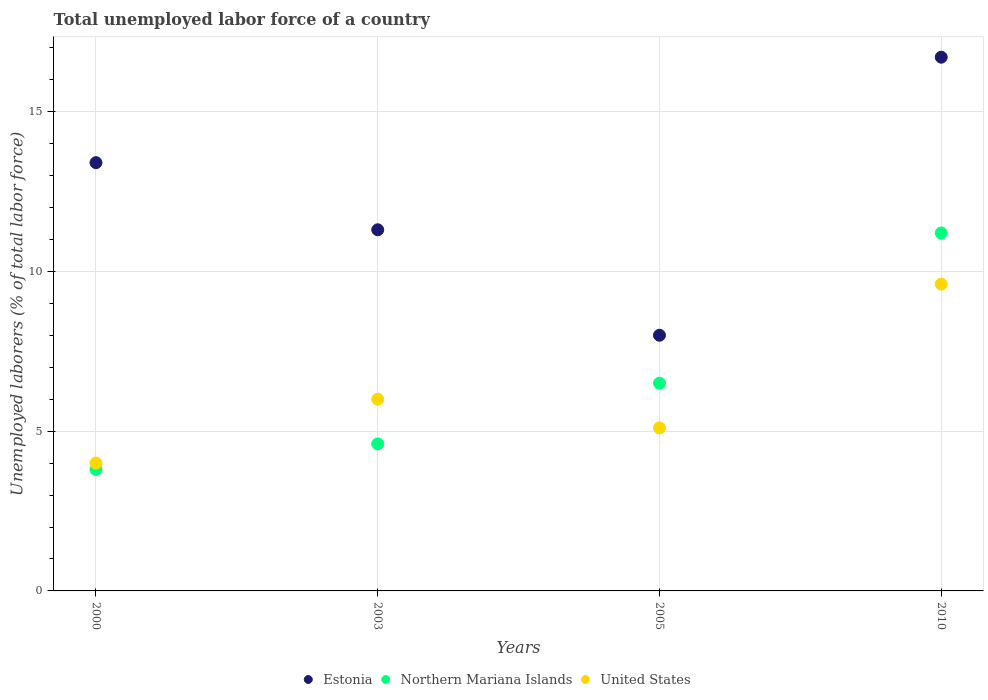How many different coloured dotlines are there?
Offer a terse response. 3. What is the total unemployed labor force in Estonia in 2003?
Your response must be concise. 11.3. Across all years, what is the maximum total unemployed labor force in Estonia?
Your answer should be very brief. 16.7. Across all years, what is the minimum total unemployed labor force in Northern Mariana Islands?
Ensure brevity in your answer.  3.8. What is the total total unemployed labor force in Northern Mariana Islands in the graph?
Offer a very short reply. 26.1. What is the difference between the total unemployed labor force in United States in 2000 and that in 2010?
Make the answer very short. -5.6. What is the difference between the total unemployed labor force in Northern Mariana Islands in 2003 and the total unemployed labor force in Estonia in 2000?
Give a very brief answer. -8.8. What is the average total unemployed labor force in United States per year?
Ensure brevity in your answer.  6.18. In the year 2010, what is the difference between the total unemployed labor force in Northern Mariana Islands and total unemployed labor force in Estonia?
Give a very brief answer. -5.5. In how many years, is the total unemployed labor force in United States greater than 3 %?
Provide a succinct answer. 4. What is the ratio of the total unemployed labor force in Estonia in 2000 to that in 2010?
Make the answer very short. 0.8. What is the difference between the highest and the second highest total unemployed labor force in United States?
Your response must be concise. 3.6. What is the difference between the highest and the lowest total unemployed labor force in Estonia?
Your answer should be very brief. 8.7. Is the sum of the total unemployed labor force in United States in 2003 and 2005 greater than the maximum total unemployed labor force in Estonia across all years?
Ensure brevity in your answer.  No. Is it the case that in every year, the sum of the total unemployed labor force in Northern Mariana Islands and total unemployed labor force in Estonia  is greater than the total unemployed labor force in United States?
Provide a succinct answer. Yes. Is the total unemployed labor force in United States strictly less than the total unemployed labor force in Northern Mariana Islands over the years?
Offer a terse response. No. How many years are there in the graph?
Offer a very short reply. 4. Does the graph contain any zero values?
Your answer should be very brief. No. Does the graph contain grids?
Give a very brief answer. Yes. How are the legend labels stacked?
Offer a terse response. Horizontal. What is the title of the graph?
Provide a succinct answer. Total unemployed labor force of a country. What is the label or title of the Y-axis?
Ensure brevity in your answer.  Unemployed laborers (% of total labor force). What is the Unemployed laborers (% of total labor force) in Estonia in 2000?
Keep it short and to the point. 13.4. What is the Unemployed laborers (% of total labor force) in Northern Mariana Islands in 2000?
Offer a terse response. 3.8. What is the Unemployed laborers (% of total labor force) of United States in 2000?
Keep it short and to the point. 4. What is the Unemployed laborers (% of total labor force) in Estonia in 2003?
Your answer should be compact. 11.3. What is the Unemployed laborers (% of total labor force) in Northern Mariana Islands in 2003?
Your answer should be compact. 4.6. What is the Unemployed laborers (% of total labor force) of United States in 2003?
Make the answer very short. 6. What is the Unemployed laborers (% of total labor force) in Estonia in 2005?
Offer a very short reply. 8. What is the Unemployed laborers (% of total labor force) of Northern Mariana Islands in 2005?
Your response must be concise. 6.5. What is the Unemployed laborers (% of total labor force) in United States in 2005?
Offer a terse response. 5.1. What is the Unemployed laborers (% of total labor force) of Estonia in 2010?
Offer a terse response. 16.7. What is the Unemployed laborers (% of total labor force) in Northern Mariana Islands in 2010?
Provide a succinct answer. 11.2. What is the Unemployed laborers (% of total labor force) in United States in 2010?
Your answer should be very brief. 9.6. Across all years, what is the maximum Unemployed laborers (% of total labor force) of Estonia?
Provide a succinct answer. 16.7. Across all years, what is the maximum Unemployed laborers (% of total labor force) of Northern Mariana Islands?
Provide a succinct answer. 11.2. Across all years, what is the maximum Unemployed laborers (% of total labor force) of United States?
Offer a terse response. 9.6. Across all years, what is the minimum Unemployed laborers (% of total labor force) of Northern Mariana Islands?
Offer a terse response. 3.8. What is the total Unemployed laborers (% of total labor force) in Estonia in the graph?
Provide a short and direct response. 49.4. What is the total Unemployed laborers (% of total labor force) of Northern Mariana Islands in the graph?
Offer a terse response. 26.1. What is the total Unemployed laborers (% of total labor force) in United States in the graph?
Provide a succinct answer. 24.7. What is the difference between the Unemployed laborers (% of total labor force) in Northern Mariana Islands in 2000 and that in 2003?
Your answer should be compact. -0.8. What is the difference between the Unemployed laborers (% of total labor force) in United States in 2000 and that in 2003?
Your answer should be compact. -2. What is the difference between the Unemployed laborers (% of total labor force) in Estonia in 2000 and that in 2005?
Ensure brevity in your answer.  5.4. What is the difference between the Unemployed laborers (% of total labor force) in Northern Mariana Islands in 2000 and that in 2005?
Offer a terse response. -2.7. What is the difference between the Unemployed laborers (% of total labor force) of Estonia in 2000 and that in 2010?
Keep it short and to the point. -3.3. What is the difference between the Unemployed laborers (% of total labor force) in United States in 2000 and that in 2010?
Make the answer very short. -5.6. What is the difference between the Unemployed laborers (% of total labor force) of Northern Mariana Islands in 2003 and that in 2010?
Your answer should be very brief. -6.6. What is the difference between the Unemployed laborers (% of total labor force) of United States in 2003 and that in 2010?
Offer a very short reply. -3.6. What is the difference between the Unemployed laborers (% of total labor force) of Estonia in 2005 and that in 2010?
Make the answer very short. -8.7. What is the difference between the Unemployed laborers (% of total labor force) in Northern Mariana Islands in 2005 and that in 2010?
Offer a very short reply. -4.7. What is the difference between the Unemployed laborers (% of total labor force) in Estonia in 2000 and the Unemployed laborers (% of total labor force) in Northern Mariana Islands in 2005?
Provide a succinct answer. 6.9. What is the difference between the Unemployed laborers (% of total labor force) in Estonia in 2003 and the Unemployed laborers (% of total labor force) in Northern Mariana Islands in 2005?
Provide a short and direct response. 4.8. What is the difference between the Unemployed laborers (% of total labor force) of Estonia in 2003 and the Unemployed laborers (% of total labor force) of United States in 2005?
Keep it short and to the point. 6.2. What is the difference between the Unemployed laborers (% of total labor force) of Northern Mariana Islands in 2003 and the Unemployed laborers (% of total labor force) of United States in 2005?
Your answer should be very brief. -0.5. What is the difference between the Unemployed laborers (% of total labor force) of Estonia in 2003 and the Unemployed laborers (% of total labor force) of Northern Mariana Islands in 2010?
Your response must be concise. 0.1. What is the difference between the Unemployed laborers (% of total labor force) in Estonia in 2003 and the Unemployed laborers (% of total labor force) in United States in 2010?
Give a very brief answer. 1.7. What is the difference between the Unemployed laborers (% of total labor force) in Northern Mariana Islands in 2003 and the Unemployed laborers (% of total labor force) in United States in 2010?
Offer a terse response. -5. What is the difference between the Unemployed laborers (% of total labor force) of Estonia in 2005 and the Unemployed laborers (% of total labor force) of Northern Mariana Islands in 2010?
Provide a succinct answer. -3.2. What is the difference between the Unemployed laborers (% of total labor force) of Northern Mariana Islands in 2005 and the Unemployed laborers (% of total labor force) of United States in 2010?
Your answer should be compact. -3.1. What is the average Unemployed laborers (% of total labor force) in Estonia per year?
Offer a very short reply. 12.35. What is the average Unemployed laborers (% of total labor force) in Northern Mariana Islands per year?
Keep it short and to the point. 6.53. What is the average Unemployed laborers (% of total labor force) of United States per year?
Your answer should be very brief. 6.17. In the year 2000, what is the difference between the Unemployed laborers (% of total labor force) in Estonia and Unemployed laborers (% of total labor force) in United States?
Ensure brevity in your answer.  9.4. In the year 2000, what is the difference between the Unemployed laborers (% of total labor force) in Northern Mariana Islands and Unemployed laborers (% of total labor force) in United States?
Ensure brevity in your answer.  -0.2. In the year 2003, what is the difference between the Unemployed laborers (% of total labor force) of Estonia and Unemployed laborers (% of total labor force) of Northern Mariana Islands?
Offer a terse response. 6.7. In the year 2003, what is the difference between the Unemployed laborers (% of total labor force) of Estonia and Unemployed laborers (% of total labor force) of United States?
Your answer should be compact. 5.3. In the year 2005, what is the difference between the Unemployed laborers (% of total labor force) of Estonia and Unemployed laborers (% of total labor force) of United States?
Offer a very short reply. 2.9. In the year 2005, what is the difference between the Unemployed laborers (% of total labor force) in Northern Mariana Islands and Unemployed laborers (% of total labor force) in United States?
Provide a short and direct response. 1.4. In the year 2010, what is the difference between the Unemployed laborers (% of total labor force) of Estonia and Unemployed laborers (% of total labor force) of United States?
Make the answer very short. 7.1. What is the ratio of the Unemployed laborers (% of total labor force) of Estonia in 2000 to that in 2003?
Your response must be concise. 1.19. What is the ratio of the Unemployed laborers (% of total labor force) of Northern Mariana Islands in 2000 to that in 2003?
Offer a very short reply. 0.83. What is the ratio of the Unemployed laborers (% of total labor force) in United States in 2000 to that in 2003?
Make the answer very short. 0.67. What is the ratio of the Unemployed laborers (% of total labor force) of Estonia in 2000 to that in 2005?
Offer a terse response. 1.68. What is the ratio of the Unemployed laborers (% of total labor force) in Northern Mariana Islands in 2000 to that in 2005?
Your response must be concise. 0.58. What is the ratio of the Unemployed laborers (% of total labor force) of United States in 2000 to that in 2005?
Your answer should be compact. 0.78. What is the ratio of the Unemployed laborers (% of total labor force) of Estonia in 2000 to that in 2010?
Keep it short and to the point. 0.8. What is the ratio of the Unemployed laborers (% of total labor force) of Northern Mariana Islands in 2000 to that in 2010?
Your response must be concise. 0.34. What is the ratio of the Unemployed laborers (% of total labor force) of United States in 2000 to that in 2010?
Ensure brevity in your answer.  0.42. What is the ratio of the Unemployed laborers (% of total labor force) in Estonia in 2003 to that in 2005?
Your answer should be very brief. 1.41. What is the ratio of the Unemployed laborers (% of total labor force) of Northern Mariana Islands in 2003 to that in 2005?
Provide a short and direct response. 0.71. What is the ratio of the Unemployed laborers (% of total labor force) of United States in 2003 to that in 2005?
Make the answer very short. 1.18. What is the ratio of the Unemployed laborers (% of total labor force) in Estonia in 2003 to that in 2010?
Offer a very short reply. 0.68. What is the ratio of the Unemployed laborers (% of total labor force) of Northern Mariana Islands in 2003 to that in 2010?
Your answer should be very brief. 0.41. What is the ratio of the Unemployed laborers (% of total labor force) in United States in 2003 to that in 2010?
Offer a terse response. 0.62. What is the ratio of the Unemployed laborers (% of total labor force) of Estonia in 2005 to that in 2010?
Your answer should be compact. 0.48. What is the ratio of the Unemployed laborers (% of total labor force) in Northern Mariana Islands in 2005 to that in 2010?
Provide a short and direct response. 0.58. What is the ratio of the Unemployed laborers (% of total labor force) in United States in 2005 to that in 2010?
Ensure brevity in your answer.  0.53. What is the difference between the highest and the second highest Unemployed laborers (% of total labor force) in Estonia?
Your answer should be compact. 3.3. What is the difference between the highest and the second highest Unemployed laborers (% of total labor force) of Northern Mariana Islands?
Make the answer very short. 4.7. What is the difference between the highest and the second highest Unemployed laborers (% of total labor force) of United States?
Provide a succinct answer. 3.6. What is the difference between the highest and the lowest Unemployed laborers (% of total labor force) in Estonia?
Offer a very short reply. 8.7. What is the difference between the highest and the lowest Unemployed laborers (% of total labor force) in Northern Mariana Islands?
Keep it short and to the point. 7.4. 